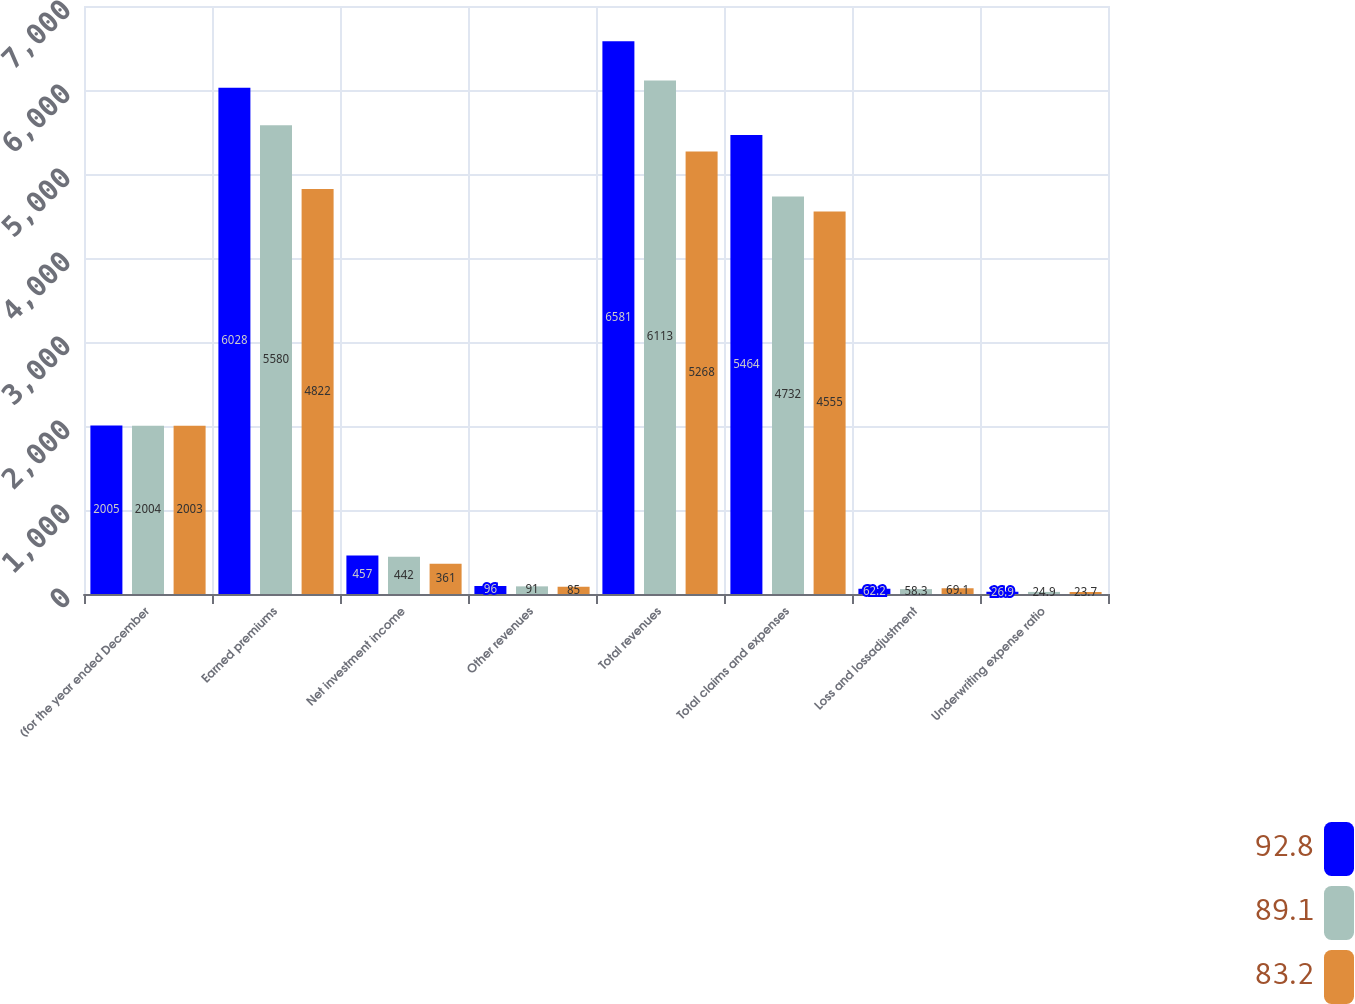<chart> <loc_0><loc_0><loc_500><loc_500><stacked_bar_chart><ecel><fcel>(for the year ended December<fcel>Earned premiums<fcel>Net investment income<fcel>Other revenues<fcel>Total revenues<fcel>Total claims and expenses<fcel>Loss and lossadjustment<fcel>Underwriting expense ratio<nl><fcel>92.8<fcel>2005<fcel>6028<fcel>457<fcel>96<fcel>6581<fcel>5464<fcel>62.2<fcel>26.9<nl><fcel>89.1<fcel>2004<fcel>5580<fcel>442<fcel>91<fcel>6113<fcel>4732<fcel>58.3<fcel>24.9<nl><fcel>83.2<fcel>2003<fcel>4822<fcel>361<fcel>85<fcel>5268<fcel>4555<fcel>69.1<fcel>23.7<nl></chart> 